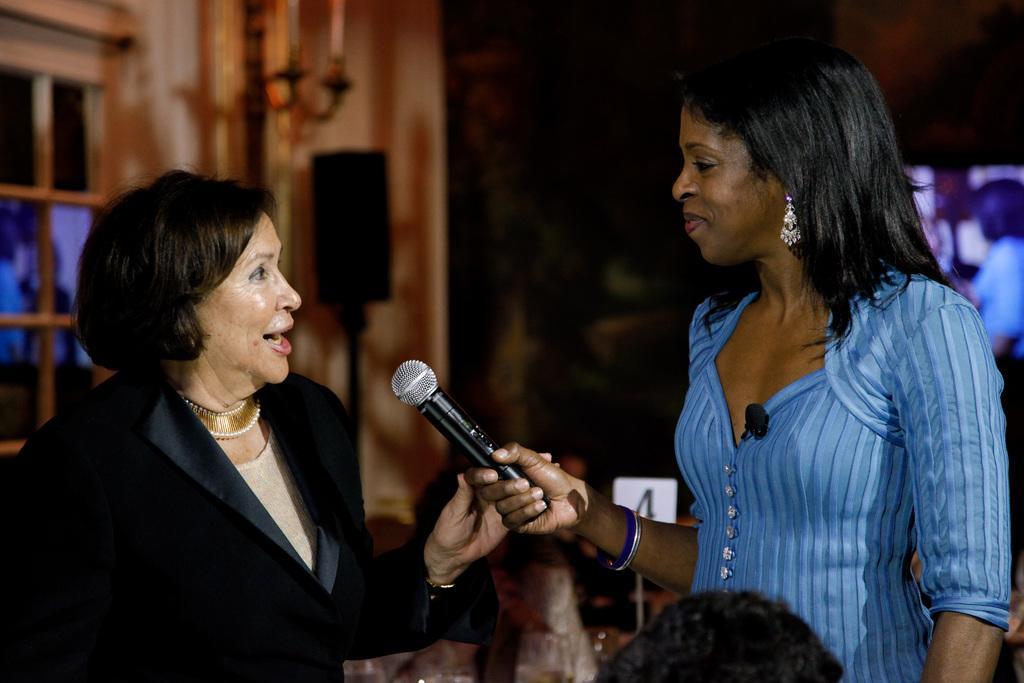Could you give a brief overview of what you see in this image? There are two women standing. One women is holding the mike and the other woman is speaking. At background I can see a speaker which is black in color. I think these are the candles on the candle stand. This looks like a window. 